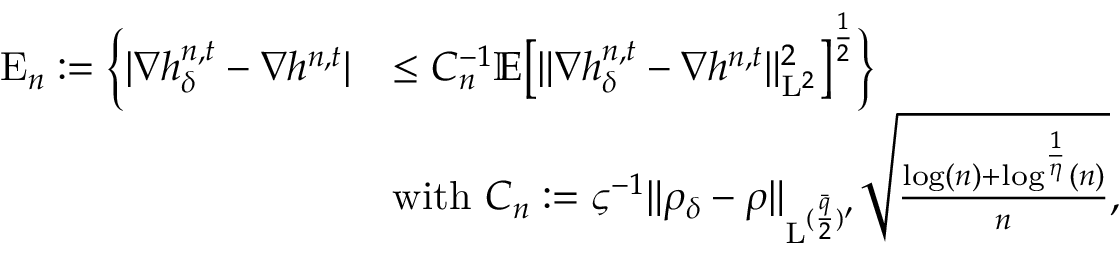<formula> <loc_0><loc_0><loc_500><loc_500>\begin{array} { r l } { E _ { n } \colon = \left \{ | \nabla h _ { \delta } ^ { n , t } - \nabla h ^ { n , t } | } & { \leq C _ { n } ^ { - 1 } \mathbb { E } \left [ \| \nabla h _ { \delta } ^ { n , t } - \nabla h ^ { n , t } \| _ { L ^ { 2 } } ^ { 2 } \right ] ^ { \frac { 1 } { 2 } } \right \} } \\ & { w i t h C _ { n } \colon = \varsigma ^ { - 1 } \| \rho _ { \delta } - \rho \| _ { L ^ { ( \frac { \bar { q } } { 2 } ) ^ { \prime } } } \sqrt { \frac { \log ( n ) + \log ^ { \frac { 1 } { \eta } } ( n ) } { n } } , } \end{array}</formula> 